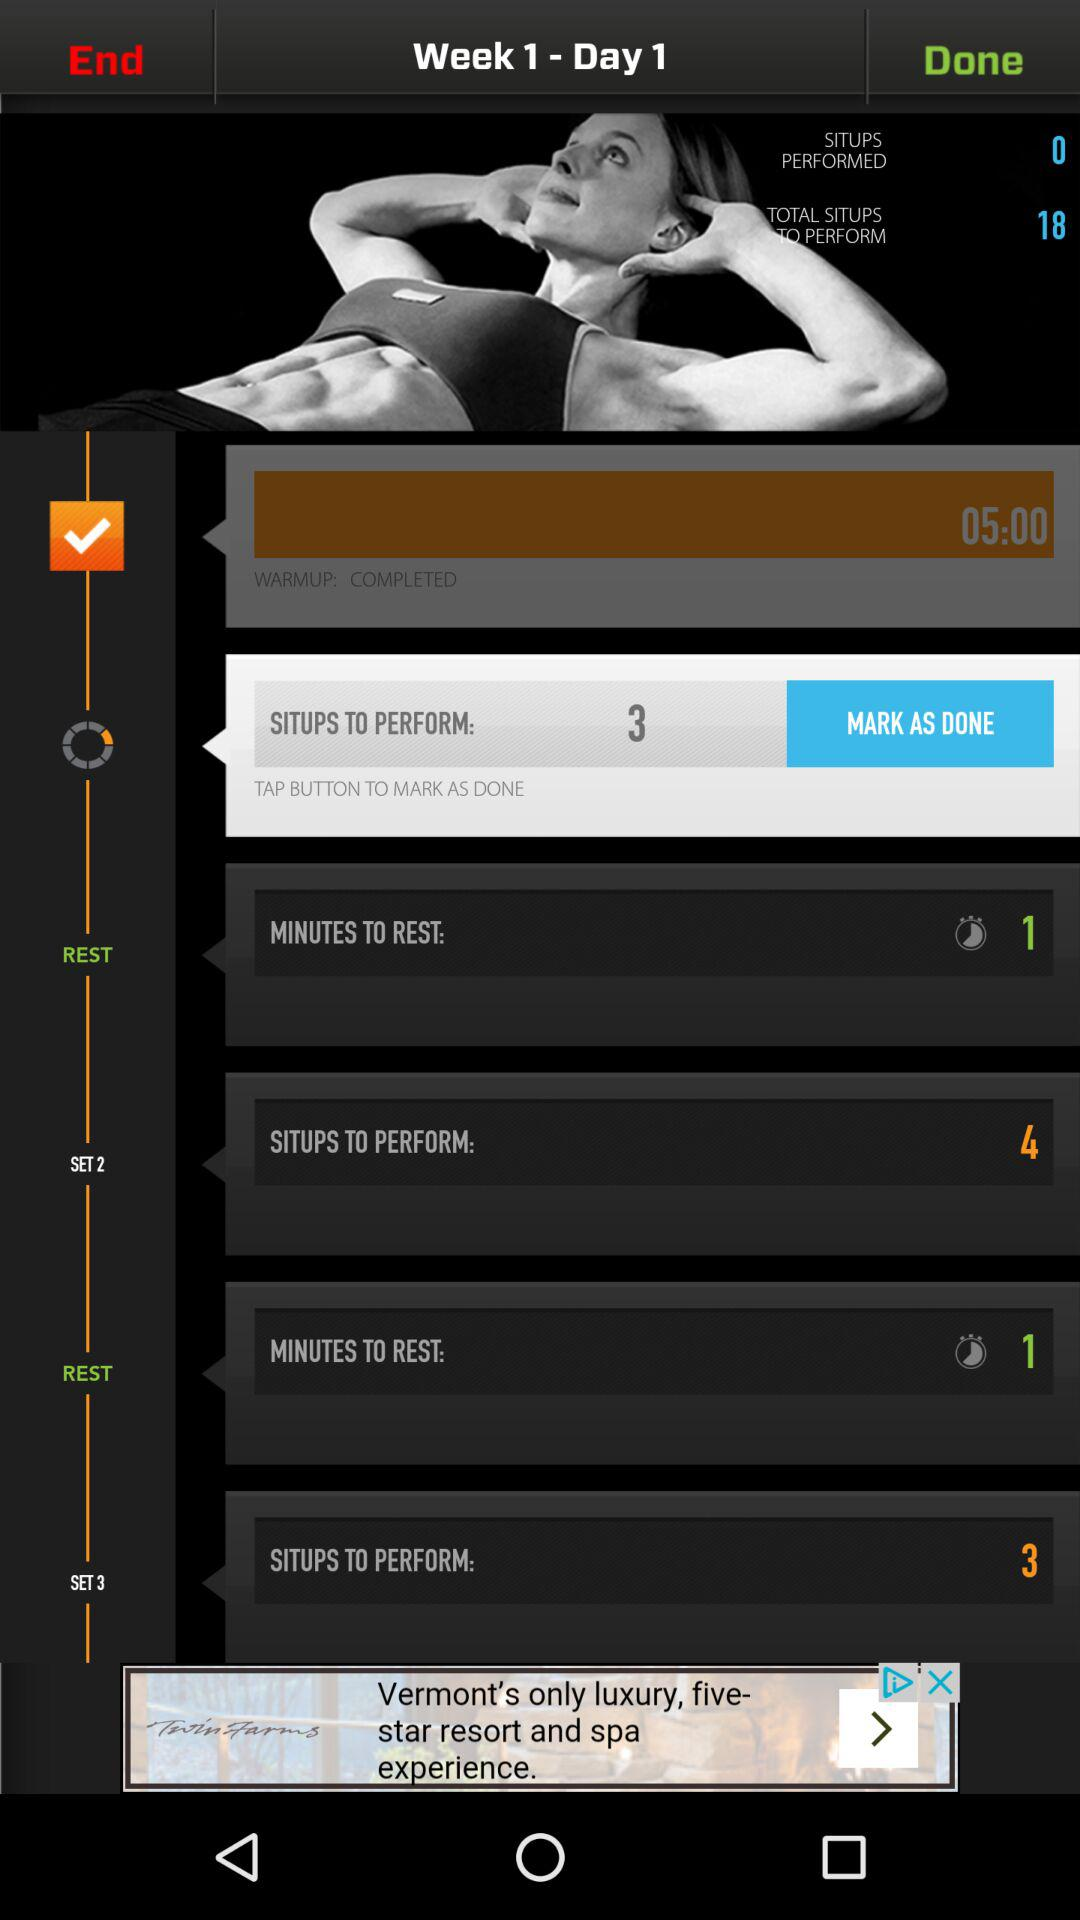How many minutes are there to rest after set 2? There is 1 minute to rest after set 2. 